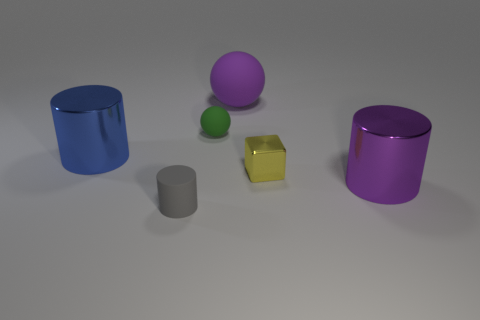Is the shape of the blue object the same as the gray rubber object?
Your response must be concise. Yes. Is there any other thing that is the same material as the small gray thing?
Offer a very short reply. Yes. The purple matte ball has what size?
Your answer should be compact. Large. What is the color of the big object that is behind the tiny yellow block and in front of the big sphere?
Keep it short and to the point. Blue. Are there more green rubber things than large cyan objects?
Keep it short and to the point. Yes. How many objects are either small cyan metallic cylinders or things in front of the yellow object?
Your response must be concise. 2. Do the purple metal thing and the yellow object have the same size?
Ensure brevity in your answer.  No. Are there any tiny yellow objects left of the big blue shiny thing?
Keep it short and to the point. No. There is a cylinder that is right of the big blue thing and behind the small matte cylinder; what size is it?
Provide a succinct answer. Large. What number of things are either shiny objects or tiny matte objects?
Your answer should be very brief. 5. 